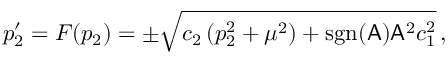<formula> <loc_0><loc_0><loc_500><loc_500>p _ { 2 } ^ { \prime } = F ( p _ { 2 } ) = \pm \sqrt { c _ { 2 } \, ( p _ { 2 } ^ { 2 } + \mu ^ { 2 } ) + s g n ( A ) A ^ { 2 } c _ { 1 } ^ { 2 } } \, ,</formula> 